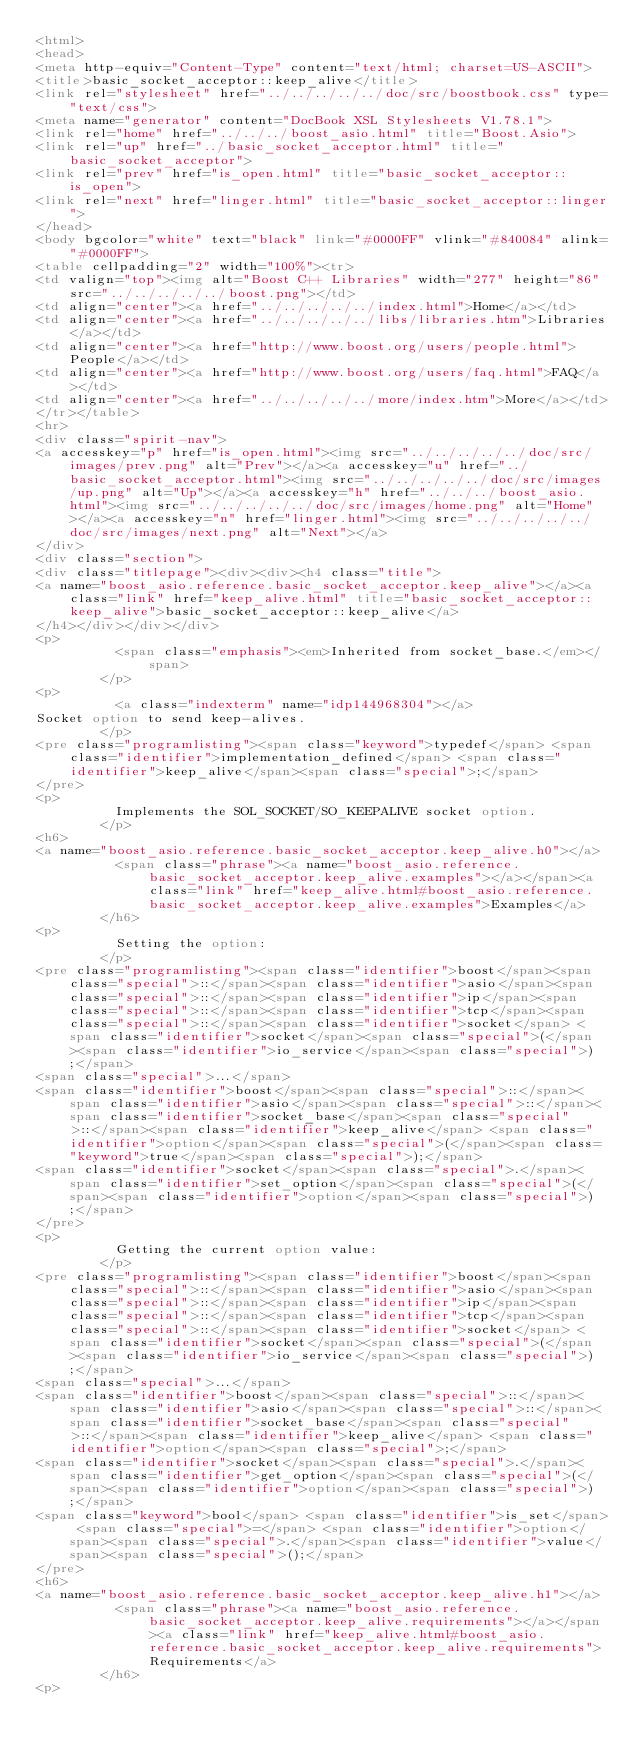Convert code to text. <code><loc_0><loc_0><loc_500><loc_500><_HTML_><html>
<head>
<meta http-equiv="Content-Type" content="text/html; charset=US-ASCII">
<title>basic_socket_acceptor::keep_alive</title>
<link rel="stylesheet" href="../../../../../doc/src/boostbook.css" type="text/css">
<meta name="generator" content="DocBook XSL Stylesheets V1.78.1">
<link rel="home" href="../../../boost_asio.html" title="Boost.Asio">
<link rel="up" href="../basic_socket_acceptor.html" title="basic_socket_acceptor">
<link rel="prev" href="is_open.html" title="basic_socket_acceptor::is_open">
<link rel="next" href="linger.html" title="basic_socket_acceptor::linger">
</head>
<body bgcolor="white" text="black" link="#0000FF" vlink="#840084" alink="#0000FF">
<table cellpadding="2" width="100%"><tr>
<td valign="top"><img alt="Boost C++ Libraries" width="277" height="86" src="../../../../../boost.png"></td>
<td align="center"><a href="../../../../../index.html">Home</a></td>
<td align="center"><a href="../../../../../libs/libraries.htm">Libraries</a></td>
<td align="center"><a href="http://www.boost.org/users/people.html">People</a></td>
<td align="center"><a href="http://www.boost.org/users/faq.html">FAQ</a></td>
<td align="center"><a href="../../../../../more/index.htm">More</a></td>
</tr></table>
<hr>
<div class="spirit-nav">
<a accesskey="p" href="is_open.html"><img src="../../../../../doc/src/images/prev.png" alt="Prev"></a><a accesskey="u" href="../basic_socket_acceptor.html"><img src="../../../../../doc/src/images/up.png" alt="Up"></a><a accesskey="h" href="../../../boost_asio.html"><img src="../../../../../doc/src/images/home.png" alt="Home"></a><a accesskey="n" href="linger.html"><img src="../../../../../doc/src/images/next.png" alt="Next"></a>
</div>
<div class="section">
<div class="titlepage"><div><div><h4 class="title">
<a name="boost_asio.reference.basic_socket_acceptor.keep_alive"></a><a class="link" href="keep_alive.html" title="basic_socket_acceptor::keep_alive">basic_socket_acceptor::keep_alive</a>
</h4></div></div></div>
<p>
          <span class="emphasis"><em>Inherited from socket_base.</em></span>
        </p>
<p>
          <a class="indexterm" name="idp144968304"></a> 
Socket option to send keep-alives.
        </p>
<pre class="programlisting"><span class="keyword">typedef</span> <span class="identifier">implementation_defined</span> <span class="identifier">keep_alive</span><span class="special">;</span>
</pre>
<p>
          Implements the SOL_SOCKET/SO_KEEPALIVE socket option.
        </p>
<h6>
<a name="boost_asio.reference.basic_socket_acceptor.keep_alive.h0"></a>
          <span class="phrase"><a name="boost_asio.reference.basic_socket_acceptor.keep_alive.examples"></a></span><a class="link" href="keep_alive.html#boost_asio.reference.basic_socket_acceptor.keep_alive.examples">Examples</a>
        </h6>
<p>
          Setting the option:
        </p>
<pre class="programlisting"><span class="identifier">boost</span><span class="special">::</span><span class="identifier">asio</span><span class="special">::</span><span class="identifier">ip</span><span class="special">::</span><span class="identifier">tcp</span><span class="special">::</span><span class="identifier">socket</span> <span class="identifier">socket</span><span class="special">(</span><span class="identifier">io_service</span><span class="special">);</span>
<span class="special">...</span>
<span class="identifier">boost</span><span class="special">::</span><span class="identifier">asio</span><span class="special">::</span><span class="identifier">socket_base</span><span class="special">::</span><span class="identifier">keep_alive</span> <span class="identifier">option</span><span class="special">(</span><span class="keyword">true</span><span class="special">);</span>
<span class="identifier">socket</span><span class="special">.</span><span class="identifier">set_option</span><span class="special">(</span><span class="identifier">option</span><span class="special">);</span>
</pre>
<p>
          Getting the current option value:
        </p>
<pre class="programlisting"><span class="identifier">boost</span><span class="special">::</span><span class="identifier">asio</span><span class="special">::</span><span class="identifier">ip</span><span class="special">::</span><span class="identifier">tcp</span><span class="special">::</span><span class="identifier">socket</span> <span class="identifier">socket</span><span class="special">(</span><span class="identifier">io_service</span><span class="special">);</span>
<span class="special">...</span>
<span class="identifier">boost</span><span class="special">::</span><span class="identifier">asio</span><span class="special">::</span><span class="identifier">socket_base</span><span class="special">::</span><span class="identifier">keep_alive</span> <span class="identifier">option</span><span class="special">;</span>
<span class="identifier">socket</span><span class="special">.</span><span class="identifier">get_option</span><span class="special">(</span><span class="identifier">option</span><span class="special">);</span>
<span class="keyword">bool</span> <span class="identifier">is_set</span> <span class="special">=</span> <span class="identifier">option</span><span class="special">.</span><span class="identifier">value</span><span class="special">();</span>
</pre>
<h6>
<a name="boost_asio.reference.basic_socket_acceptor.keep_alive.h1"></a>
          <span class="phrase"><a name="boost_asio.reference.basic_socket_acceptor.keep_alive.requirements"></a></span><a class="link" href="keep_alive.html#boost_asio.reference.basic_socket_acceptor.keep_alive.requirements">Requirements</a>
        </h6>
<p></code> 